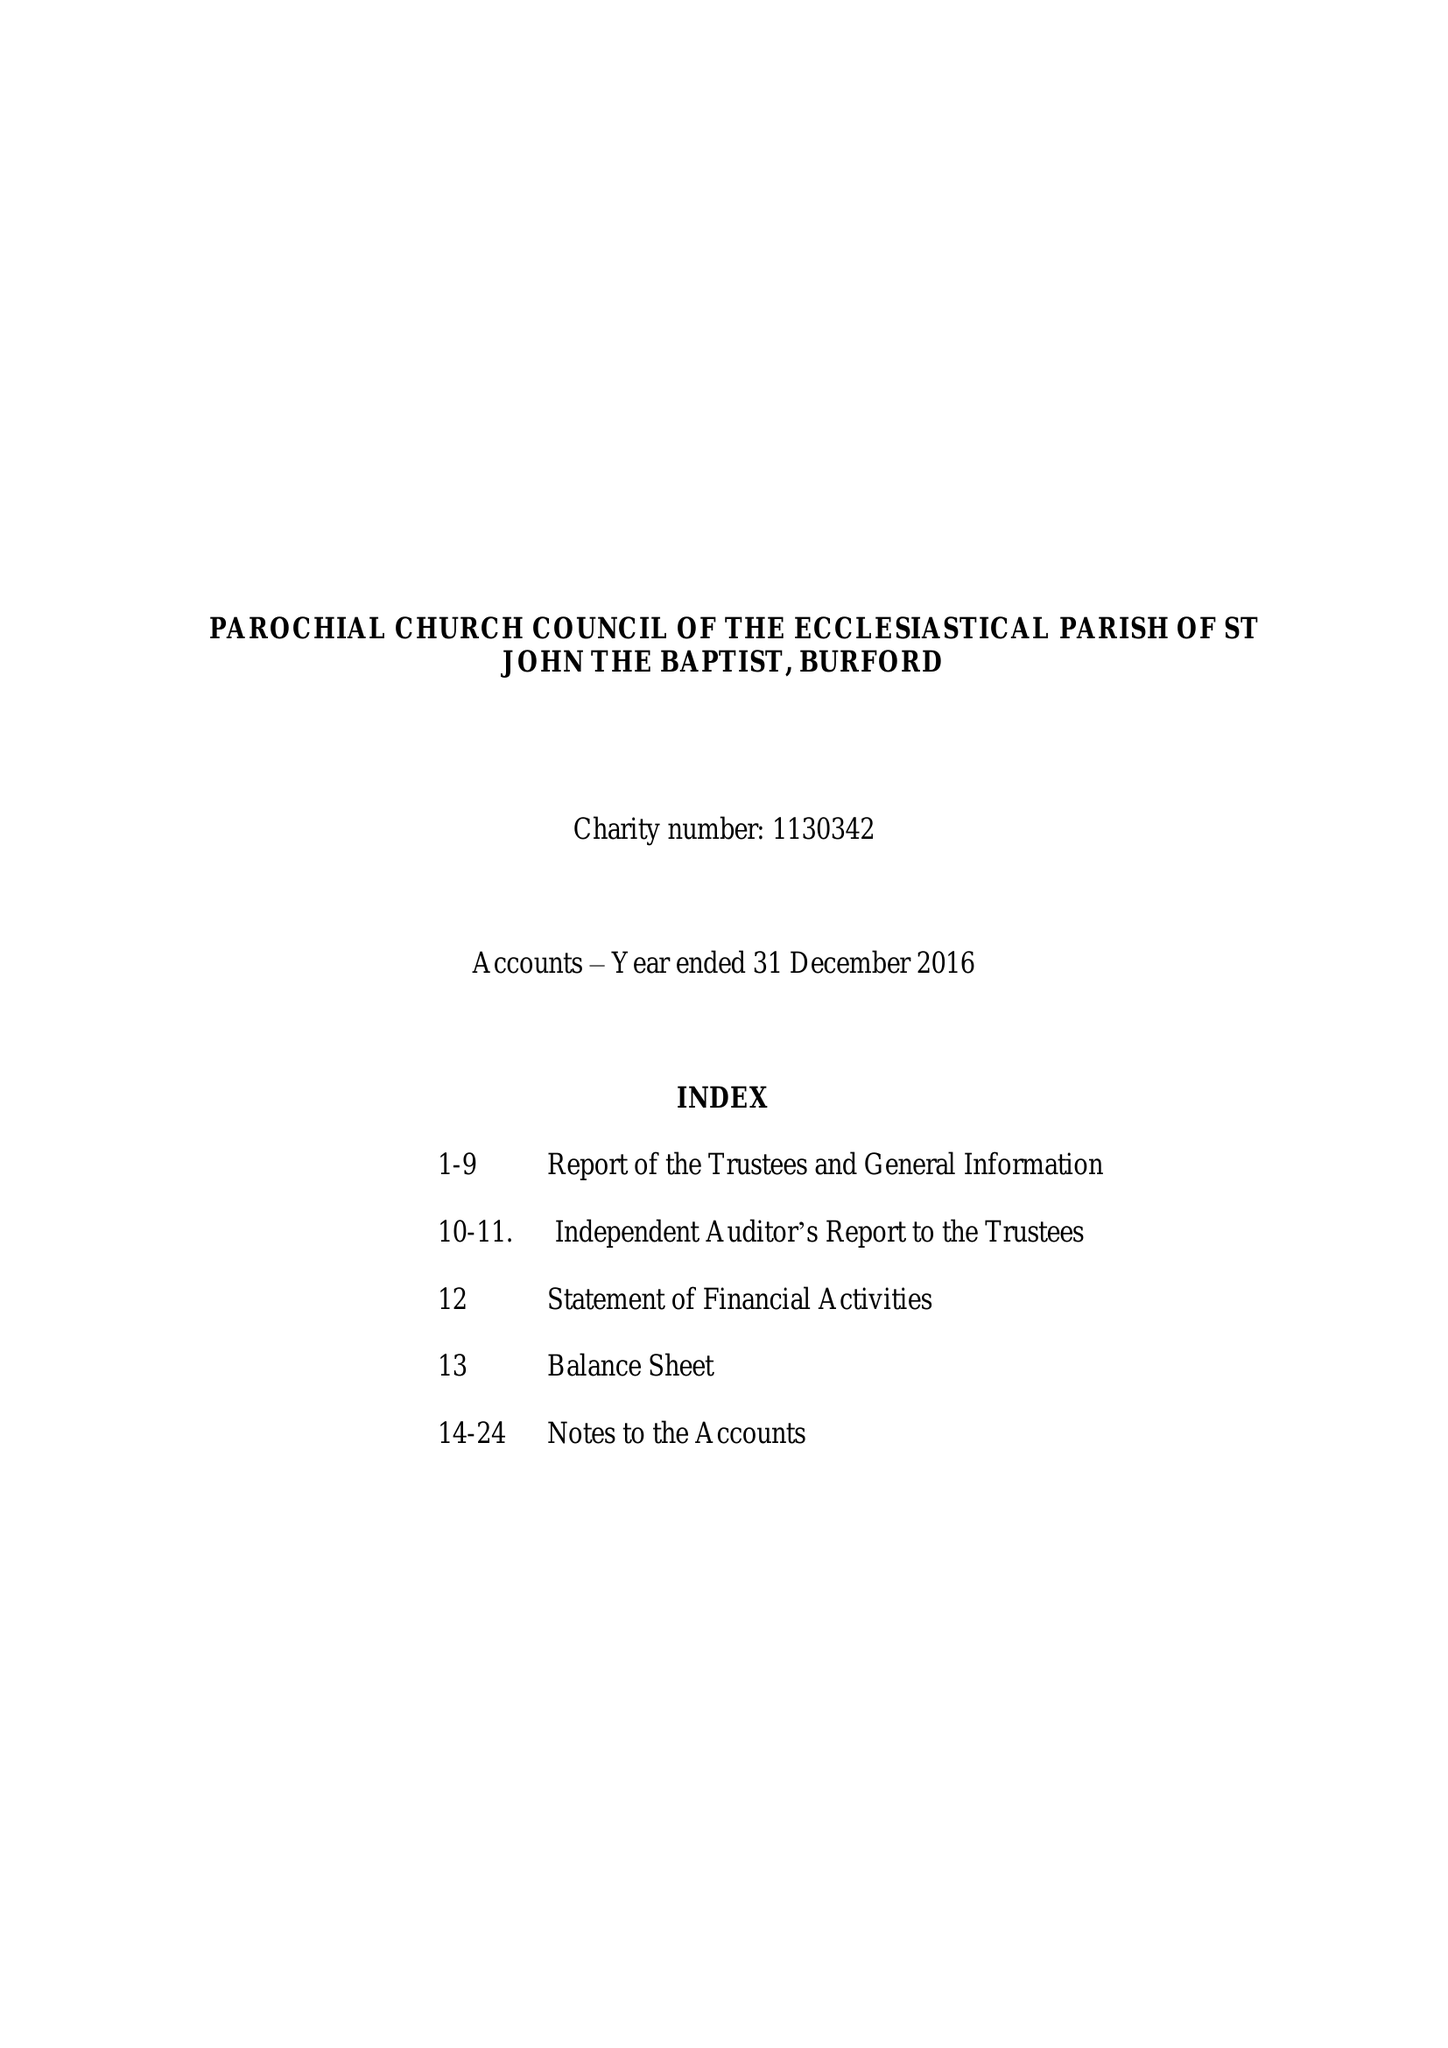What is the value for the report_date?
Answer the question using a single word or phrase. 2016-12-31 